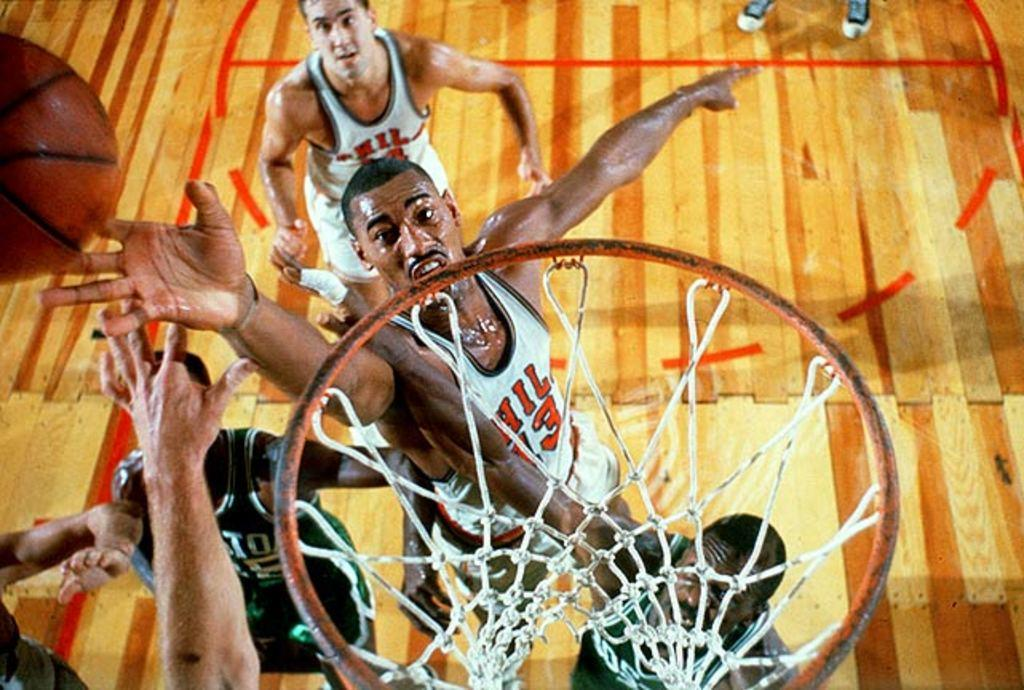What can be seen in the image? There are men standing in the image. What is the surface they are standing on? The men are standing on a wooden floor. What object is present in the image that is typically used in sports? There is a ball in the image, which is commonly used in sports. What type of basketball equipment can be seen in the image? There is a basketball basket in the image. How many geese are flying over the basketball court in the image? There are no geese present in the image; it only features men, a wooden floor, a ball, and a basketball basket. 